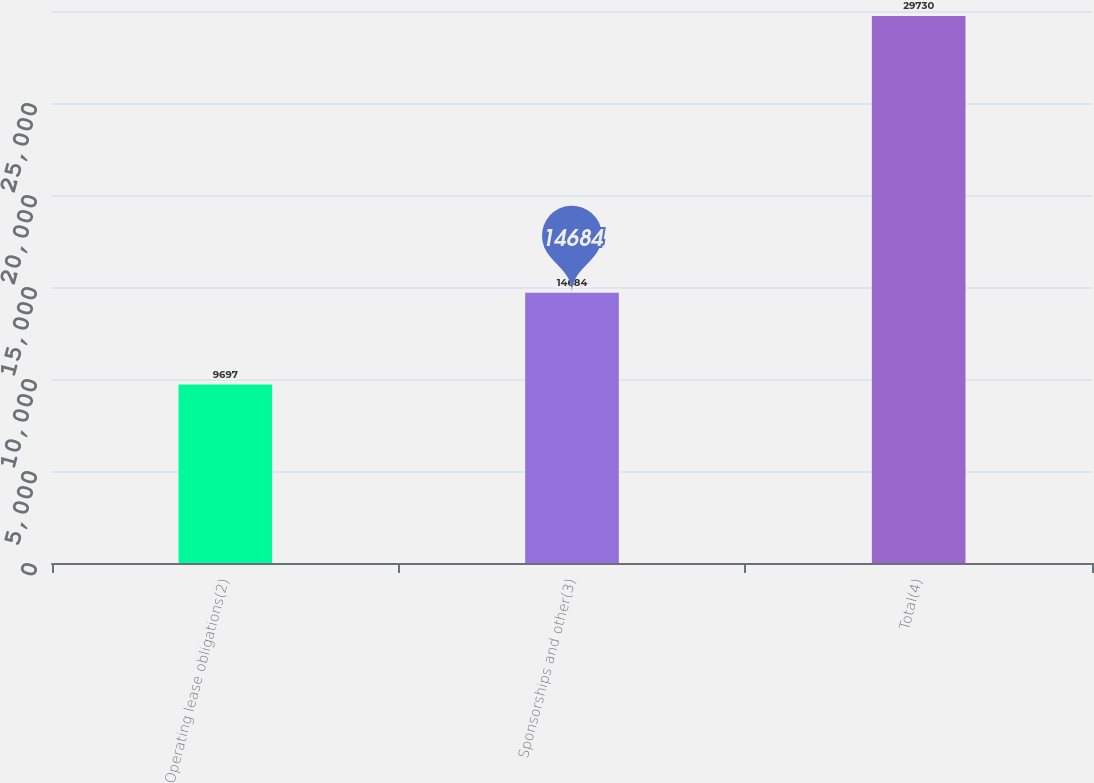Convert chart. <chart><loc_0><loc_0><loc_500><loc_500><bar_chart><fcel>Operating lease obligations(2)<fcel>Sponsorships and other(3)<fcel>Total(4)<nl><fcel>9697<fcel>14684<fcel>29730<nl></chart> 